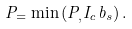Convert formula to latex. <formula><loc_0><loc_0><loc_500><loc_500>P _ { = } \min \left ( P _ { , } I _ { c } b _ { s } \right ) .</formula> 